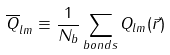Convert formula to latex. <formula><loc_0><loc_0><loc_500><loc_500>\overline { Q } _ { l m } \equiv \frac { 1 } { N _ { b } } \sum _ { b o n d s } Q _ { l m } ( \vec { r } )</formula> 